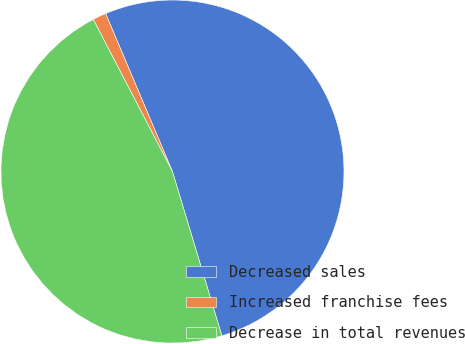Convert chart to OTSL. <chart><loc_0><loc_0><loc_500><loc_500><pie_chart><fcel>Decreased sales<fcel>Increased franchise fees<fcel>Decrease in total revenues<nl><fcel>51.72%<fcel>1.27%<fcel>47.01%<nl></chart> 